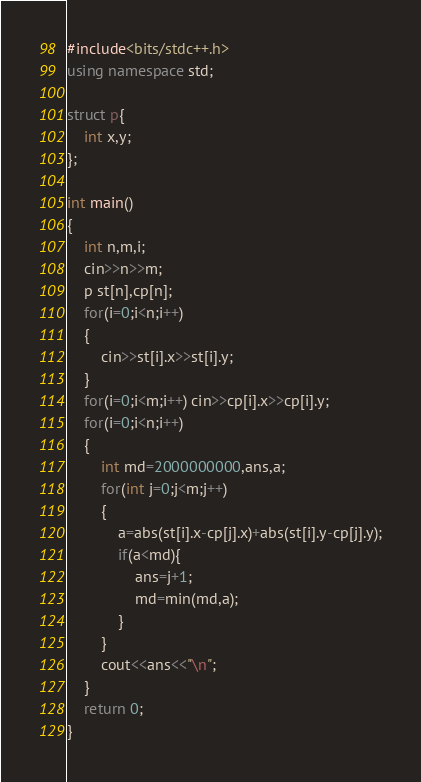Convert code to text. <code><loc_0><loc_0><loc_500><loc_500><_C++_>#include<bits/stdc++.h>
using namespace std;

struct p{
    int x,y;
};

int main()
{
    int n,m,i;
    cin>>n>>m;
    p st[n],cp[n];
    for(i=0;i<n;i++)
    {
        cin>>st[i].x>>st[i].y;
    }
    for(i=0;i<m;i++) cin>>cp[i].x>>cp[i].y;
    for(i=0;i<n;i++)
    {
        int md=2000000000,ans,a;
        for(int j=0;j<m;j++)
        {
            a=abs(st[i].x-cp[j].x)+abs(st[i].y-cp[j].y);
            if(a<md){
                ans=j+1;
                md=min(md,a);
            }
        }
        cout<<ans<<"\n";
    }
    return 0;
}
</code> 